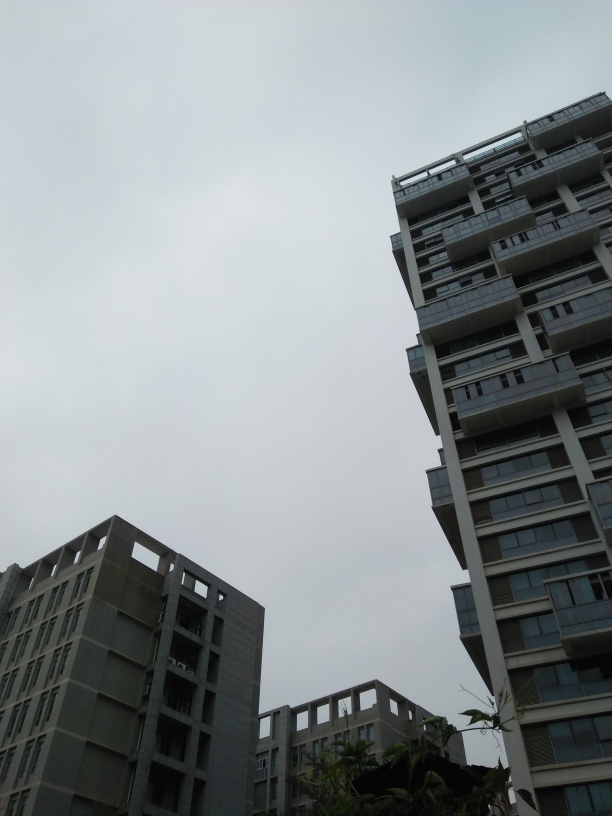Are the background details of the trees clear? The background details of the trees are moderately discernible. The overcast sky and the distance at which the trees stand contribute to a softer rendering of their features, making them appear less distinct than if they were in full sunlight or closer to the viewer. 